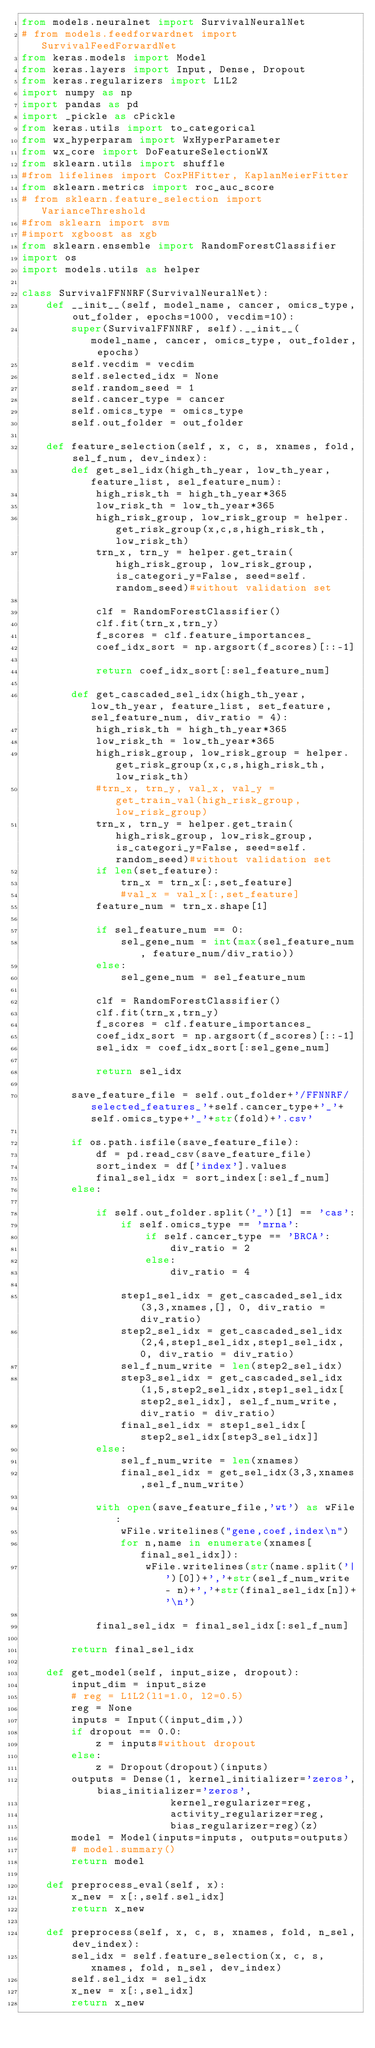Convert code to text. <code><loc_0><loc_0><loc_500><loc_500><_Python_>from models.neuralnet import SurvivalNeuralNet
# from models.feedforwardnet import SurvivalFeedForwardNet
from keras.models import Model
from keras.layers import Input, Dense, Dropout
from keras.regularizers import L1L2
import numpy as np
import pandas as pd
import _pickle as cPickle
from keras.utils import to_categorical
from wx_hyperparam import WxHyperParameter
from wx_core import DoFeatureSelectionWX
from sklearn.utils import shuffle
#from lifelines import CoxPHFitter, KaplanMeierFitter
from sklearn.metrics import roc_auc_score
# from sklearn.feature_selection import VarianceThreshold
#from sklearn import svm
#import xgboost as xgb
from sklearn.ensemble import RandomForestClassifier
import os
import models.utils as helper

class SurvivalFFNNRF(SurvivalNeuralNet):
    def __init__(self, model_name, cancer, omics_type, out_folder, epochs=1000, vecdim=10):
        super(SurvivalFFNNRF, self).__init__(model_name, cancer, omics_type, out_folder, epochs)
        self.vecdim = vecdim
        self.selected_idx = None
        self.random_seed = 1
        self.cancer_type = cancer
        self.omics_type = omics_type
        self.out_folder = out_folder

    def feature_selection(self, x, c, s, xnames, fold, sel_f_num, dev_index):  
        def get_sel_idx(high_th_year, low_th_year, feature_list, sel_feature_num):
            high_risk_th = high_th_year*365
            low_risk_th = low_th_year*365
            high_risk_group, low_risk_group = helper.get_risk_group(x,c,s,high_risk_th,low_risk_th)
            trn_x, trn_y = helper.get_train(high_risk_group, low_risk_group, is_categori_y=False, seed=self.random_seed)#without validation set

            clf = RandomForestClassifier()
            clf.fit(trn_x,trn_y)
            f_scores = clf.feature_importances_
            coef_idx_sort = np.argsort(f_scores)[::-1]

            return coef_idx_sort[:sel_feature_num]

        def get_cascaded_sel_idx(high_th_year, low_th_year, feature_list, set_feature, sel_feature_num, div_ratio = 4):
            high_risk_th = high_th_year*365
            low_risk_th = low_th_year*365
            high_risk_group, low_risk_group = helper.get_risk_group(x,c,s,high_risk_th,low_risk_th)
            #trn_x, trn_y, val_x, val_y = get_train_val(high_risk_group, low_risk_group)
            trn_x, trn_y = helper.get_train(high_risk_group, low_risk_group, is_categori_y=False, seed=self.random_seed)#without validation set
            if len(set_feature):
                trn_x = trn_x[:,set_feature]
                #val_x = val_x[:,set_feature]
            feature_num = trn_x.shape[1]

            if sel_feature_num == 0:
                sel_gene_num = int(max(sel_feature_num, feature_num/div_ratio))
            else:
                sel_gene_num = sel_feature_num

            clf = RandomForestClassifier()
            clf.fit(trn_x,trn_y)
            f_scores = clf.feature_importances_
            coef_idx_sort = np.argsort(f_scores)[::-1]            
            sel_idx = coef_idx_sort[:sel_gene_num]

            return sel_idx         

        save_feature_file = self.out_folder+'/FFNNRF/selected_features_'+self.cancer_type+'_'+self.omics_type+'_'+str(fold)+'.csv'

        if os.path.isfile(save_feature_file):
            df = pd.read_csv(save_feature_file)
            sort_index = df['index'].values
            final_sel_idx = sort_index[:sel_f_num]
        else:
            
            if self.out_folder.split('_')[1] == 'cas':
                if self.omics_type == 'mrna':
                    if self.cancer_type == 'BRCA':
                        div_ratio = 2
                    else:
                        div_ratio = 4

                step1_sel_idx = get_cascaded_sel_idx(3,3,xnames,[], 0, div_ratio = div_ratio)
                step2_sel_idx = get_cascaded_sel_idx(2,4,step1_sel_idx,step1_sel_idx, 0, div_ratio = div_ratio)
                sel_f_num_write = len(step2_sel_idx)
                step3_sel_idx = get_cascaded_sel_idx(1,5,step2_sel_idx,step1_sel_idx[step2_sel_idx], sel_f_num_write, div_ratio = div_ratio)
                final_sel_idx = step1_sel_idx[step2_sel_idx[step3_sel_idx]]            
            else:
                sel_f_num_write = len(xnames)
                final_sel_idx = get_sel_idx(3,3,xnames,sel_f_num_write)

            with open(save_feature_file,'wt') as wFile:
                wFile.writelines("gene,coef,index\n")
                for n,name in enumerate(xnames[final_sel_idx]):
                    wFile.writelines(str(name.split('|')[0])+','+str(sel_f_num_write - n)+','+str(final_sel_idx[n])+'\n')
                    
            final_sel_idx = final_sel_idx[:sel_f_num]

        return final_sel_idx        

    def get_model(self, input_size, dropout):
        input_dim = input_size
        # reg = L1L2(l1=1.0, l2=0.5)
        reg = None
        inputs = Input((input_dim,))
        if dropout == 0.0:
            z = inputs#without dropout
        else:
            z = Dropout(dropout)(inputs)
        outputs = Dense(1, kernel_initializer='zeros', bias_initializer='zeros',
                        kernel_regularizer=reg,
                        activity_regularizer=reg,
                        bias_regularizer=reg)(z)
        model = Model(inputs=inputs, outputs=outputs)
        # model.summary()
        return model

    def preprocess_eval(self, x):
        x_new = x[:,self.sel_idx]
        return x_new

    def preprocess(self, x, c, s, xnames, fold, n_sel, dev_index):
        sel_idx = self.feature_selection(x, c, s, xnames, fold, n_sel, dev_index)
        self.sel_idx = sel_idx
        x_new = x[:,sel_idx]
        return x_new</code> 